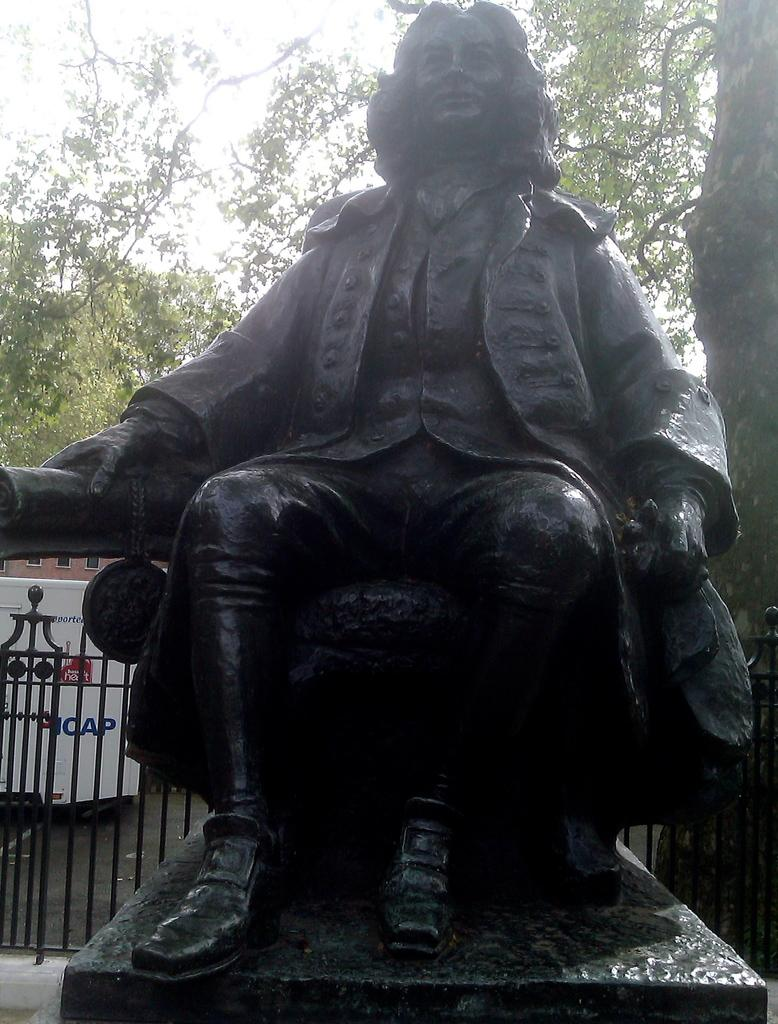What is the main subject of the image? There is a statue of a person sitting in the image. What is located behind the statue? There is a fence behind the statue. What can be seen in the background of the image? There are trees in the background of the image. What type of skirt is the statue wearing in the image? The statue is not wearing a skirt, as it is a statue and does not have clothing. 